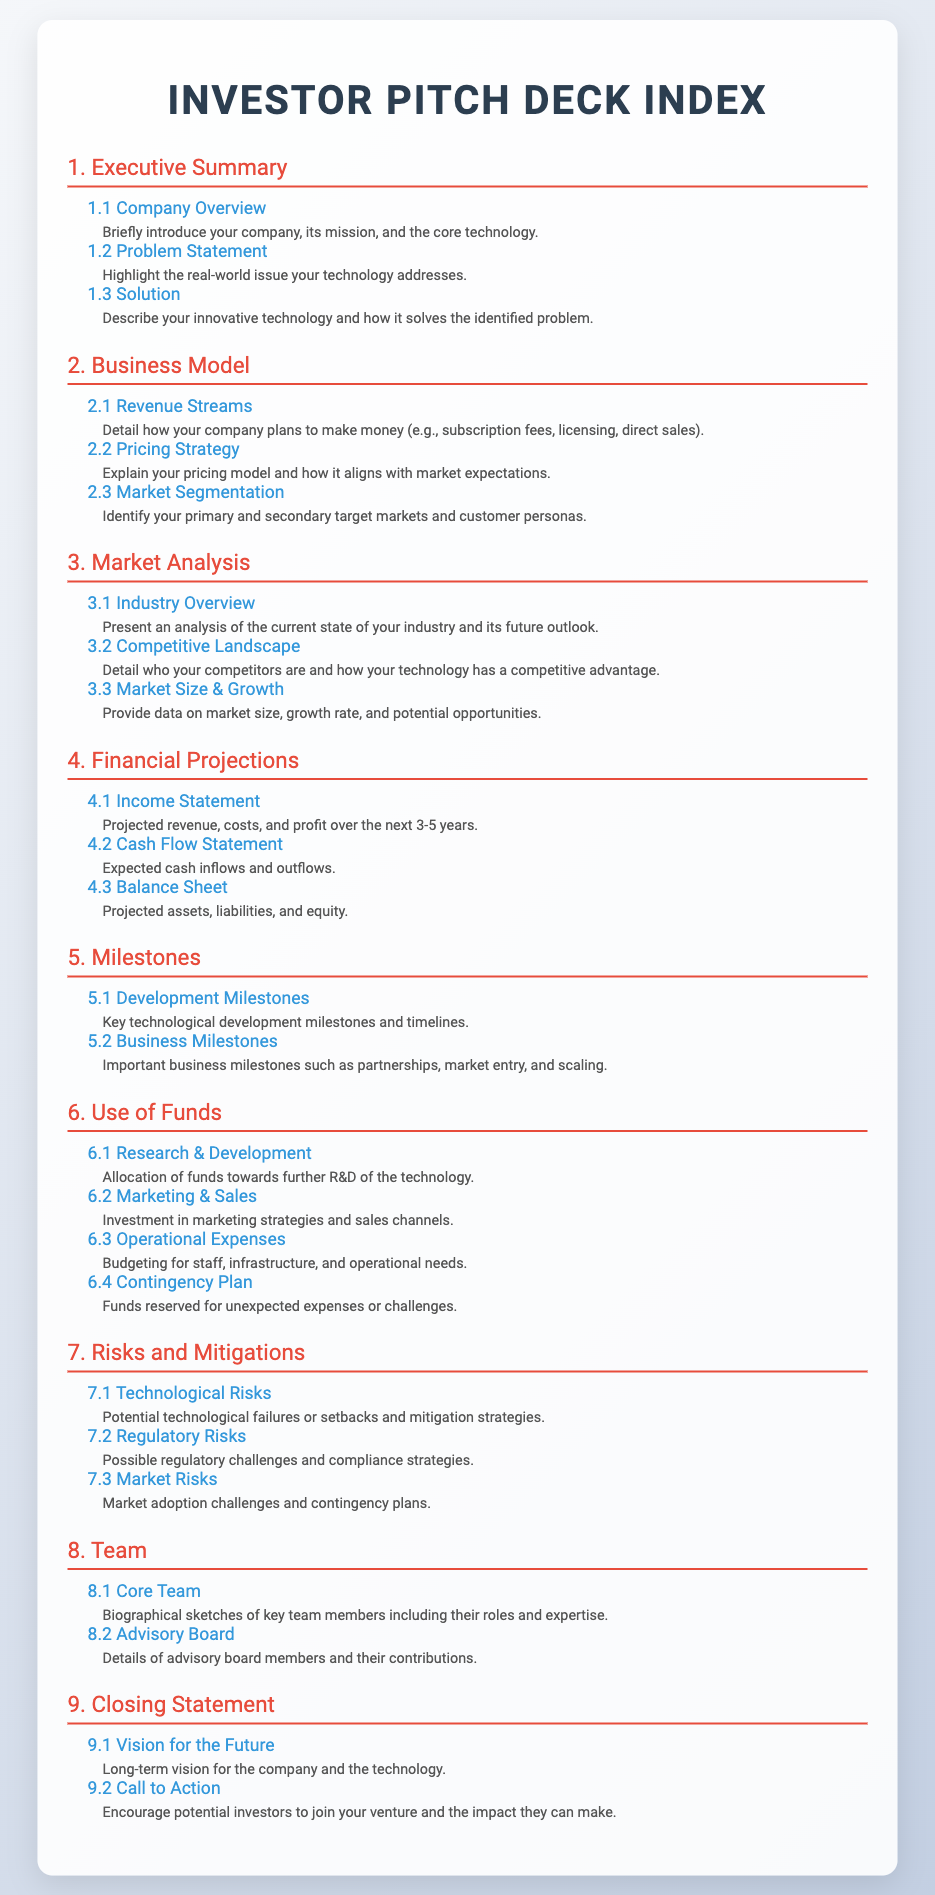What is the company overview? The company overview provides a brief introduction to the company, its mission, and the core technology.
Answer: Company Overview What are the primary revenue streams? The primary revenue streams detail how the company plans to make money such as subscription fees, licensing, and direct sales.
Answer: Revenue Streams What does the income statement project for profit? The income statement projects the revenue, costs, and profit over the next 3-5 years in the financial projections section.
Answer: Profit Which section discusses the competitive landscape? The competitive landscape is discussed in the Market Analysis section, specifically regarding competitors and competitive advantage.
Answer: Competitive Landscape How is the marketing budget categorized? The marketing budget is categorized under Marketing & Sales within the Use of Funds section.
Answer: Marketing & Sales What is included in the development milestones? Development milestones include key technological development milestones and timelines outlined in the Milestones section.
Answer: Development Milestones What types of risks are identified in the pitch deck? The pitch deck identifies technological, regulatory, and market risks in the Risks and Mitigations section.
Answer: Technological, Regulatory, Market Risks Who are the key team members? The key team members are detailed in the Core Team section, which includes biographical sketches of their roles and expertise.
Answer: Key Team Members What is the long-term vision for the company? The long-term vision for the company is specified in the Vision for the Future subsection of the Closing Statement section.
Answer: Vision for the Future 